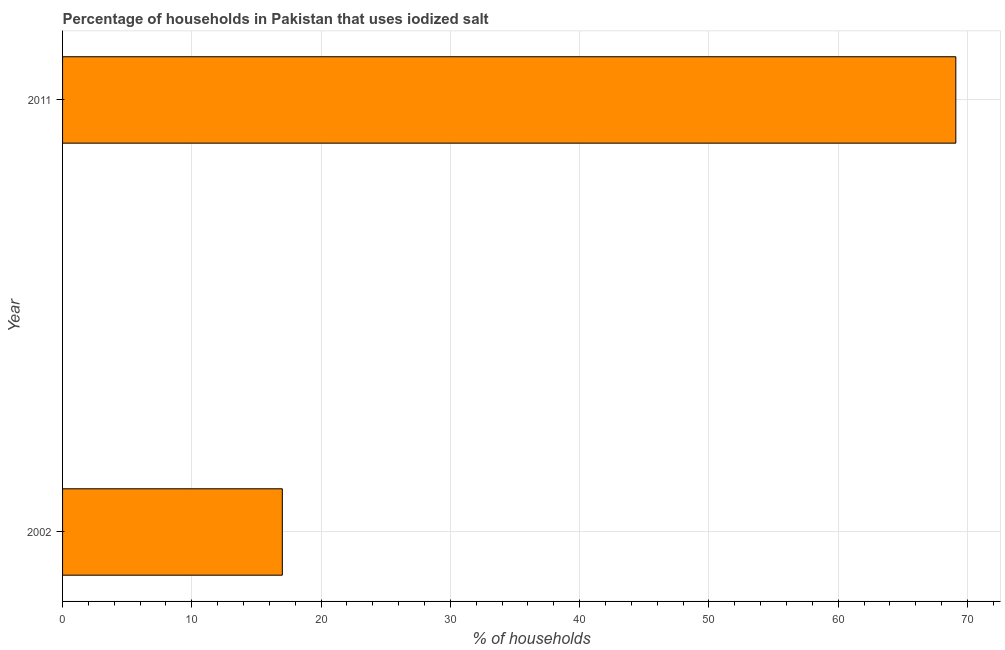Does the graph contain grids?
Ensure brevity in your answer.  Yes. What is the title of the graph?
Provide a succinct answer. Percentage of households in Pakistan that uses iodized salt. What is the label or title of the X-axis?
Your answer should be very brief. % of households. Across all years, what is the maximum percentage of households where iodized salt is consumed?
Offer a terse response. 69.1. In which year was the percentage of households where iodized salt is consumed minimum?
Your answer should be very brief. 2002. What is the sum of the percentage of households where iodized salt is consumed?
Your response must be concise. 86.1. What is the difference between the percentage of households where iodized salt is consumed in 2002 and 2011?
Your response must be concise. -52.1. What is the average percentage of households where iodized salt is consumed per year?
Your answer should be compact. 43.05. What is the median percentage of households where iodized salt is consumed?
Provide a succinct answer. 43.05. What is the ratio of the percentage of households where iodized salt is consumed in 2002 to that in 2011?
Give a very brief answer. 0.25. Is the percentage of households where iodized salt is consumed in 2002 less than that in 2011?
Your answer should be very brief. Yes. How many bars are there?
Your answer should be compact. 2. How many years are there in the graph?
Provide a short and direct response. 2. What is the difference between two consecutive major ticks on the X-axis?
Give a very brief answer. 10. Are the values on the major ticks of X-axis written in scientific E-notation?
Offer a very short reply. No. What is the % of households of 2002?
Keep it short and to the point. 17. What is the % of households in 2011?
Offer a very short reply. 69.1. What is the difference between the % of households in 2002 and 2011?
Give a very brief answer. -52.1. What is the ratio of the % of households in 2002 to that in 2011?
Offer a very short reply. 0.25. 